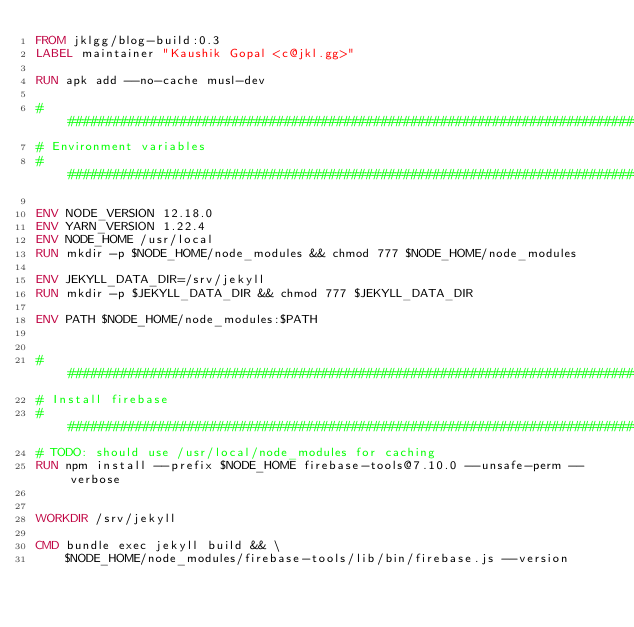Convert code to text. <code><loc_0><loc_0><loc_500><loc_500><_Dockerfile_>FROM jklgg/blog-build:0.3
LABEL maintainer "Kaushik Gopal <c@jkl.gg>"

RUN apk add --no-cache musl-dev

###############################################################################
# Environment variables
###############################################################################

ENV NODE_VERSION 12.18.0
ENV YARN_VERSION 1.22.4
ENV NODE_HOME /usr/local
RUN mkdir -p $NODE_HOME/node_modules && chmod 777 $NODE_HOME/node_modules

ENV JEKYLL_DATA_DIR=/srv/jekyll
RUN mkdir -p $JEKYLL_DATA_DIR && chmod 777 $JEKYLL_DATA_DIR

ENV PATH $NODE_HOME/node_modules:$PATH


###############################################################################
# Install firebase
###############################################################################
# TODO: should use /usr/local/node_modules for caching
RUN npm install --prefix $NODE_HOME firebase-tools@7.10.0 --unsafe-perm --verbose


WORKDIR /srv/jekyll

CMD bundle exec jekyll build && \
    $NODE_HOME/node_modules/firebase-tools/lib/bin/firebase.js --version
</code> 